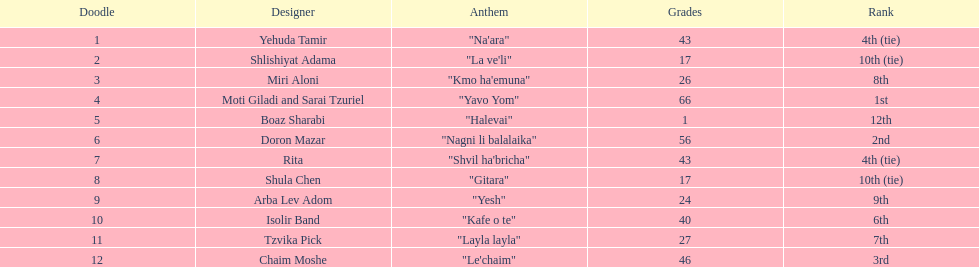Doron mazar, which artist(s) had the most points? Moti Giladi and Sarai Tzuriel. 